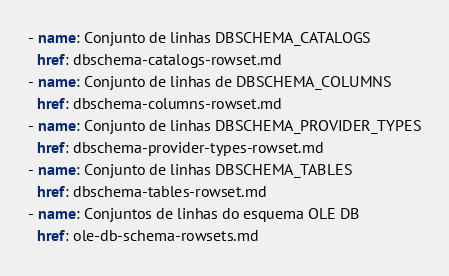<code> <loc_0><loc_0><loc_500><loc_500><_YAML_>- name: Conjunto de linhas DBSCHEMA_CATALOGS
  href: dbschema-catalogs-rowset.md
- name: Conjunto de linhas de DBSCHEMA_COLUMNS
  href: dbschema-columns-rowset.md
- name: Conjunto de linhas DBSCHEMA_PROVIDER_TYPES
  href: dbschema-provider-types-rowset.md
- name: Conjunto de linhas DBSCHEMA_TABLES
  href: dbschema-tables-rowset.md
- name: Conjuntos de linhas do esquema OLE DB
  href: ole-db-schema-rowsets.md</code> 